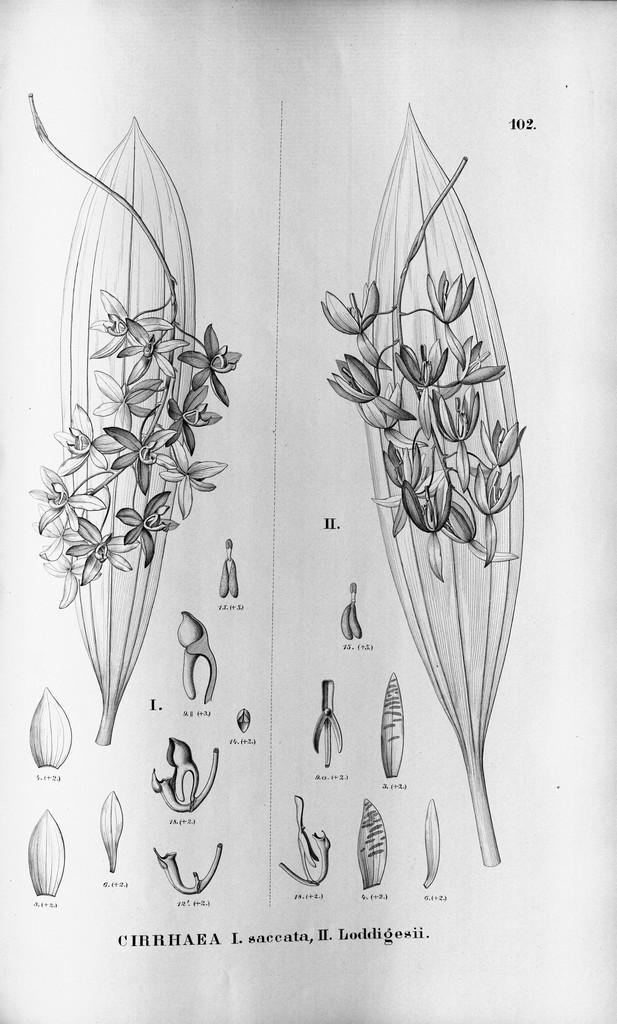Describe this image in one or two sentences. In this image there is an art in which we can see that there are flowers on the leaves. At the bottom there are buds. 